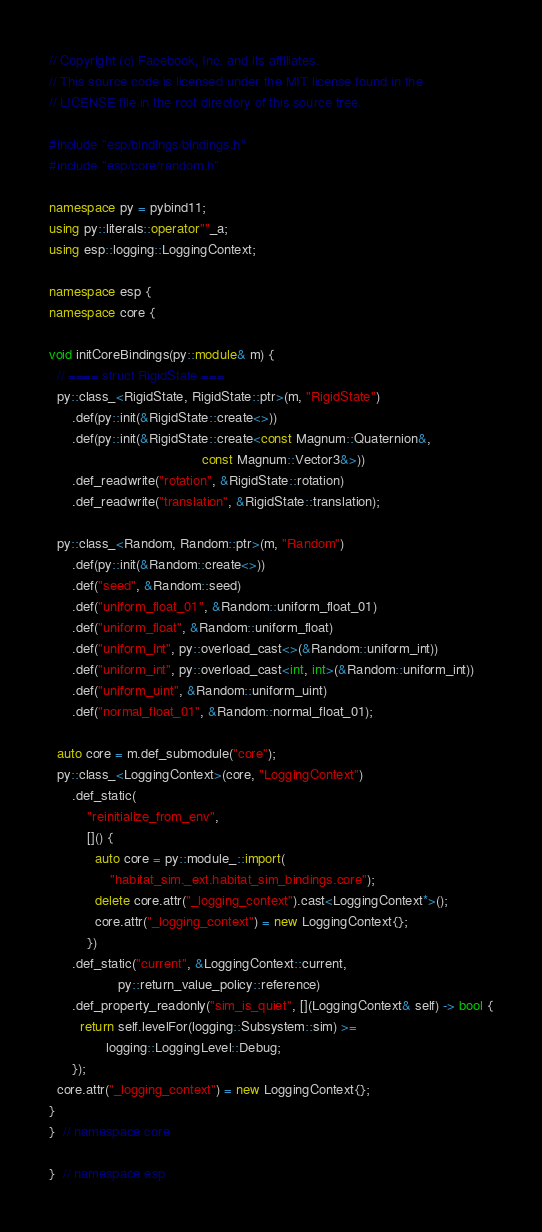<code> <loc_0><loc_0><loc_500><loc_500><_C++_>// Copyright (c) Facebook, Inc. and its affiliates.
// This source code is licensed under the MIT license found in the
// LICENSE file in the root directory of this source tree.

#include "esp/bindings/bindings.h"
#include "esp/core/random.h"

namespace py = pybind11;
using py::literals::operator""_a;
using esp::logging::LoggingContext;

namespace esp {
namespace core {

void initCoreBindings(py::module& m) {
  // ==== struct RigidState ===
  py::class_<RigidState, RigidState::ptr>(m, "RigidState")
      .def(py::init(&RigidState::create<>))
      .def(py::init(&RigidState::create<const Magnum::Quaternion&,
                                        const Magnum::Vector3&>))
      .def_readwrite("rotation", &RigidState::rotation)
      .def_readwrite("translation", &RigidState::translation);

  py::class_<Random, Random::ptr>(m, "Random")
      .def(py::init(&Random::create<>))
      .def("seed", &Random::seed)
      .def("uniform_float_01", &Random::uniform_float_01)
      .def("uniform_float", &Random::uniform_float)
      .def("uniform_int", py::overload_cast<>(&Random::uniform_int))
      .def("uniform_int", py::overload_cast<int, int>(&Random::uniform_int))
      .def("uniform_uint", &Random::uniform_uint)
      .def("normal_float_01", &Random::normal_float_01);

  auto core = m.def_submodule("core");
  py::class_<LoggingContext>(core, "LoggingContext")
      .def_static(
          "reinitialize_from_env",
          []() {
            auto core = py::module_::import(
                "habitat_sim._ext.habitat_sim_bindings.core");
            delete core.attr("_logging_context").cast<LoggingContext*>();
            core.attr("_logging_context") = new LoggingContext{};
          })
      .def_static("current", &LoggingContext::current,
                  py::return_value_policy::reference)
      .def_property_readonly("sim_is_quiet", [](LoggingContext& self) -> bool {
        return self.levelFor(logging::Subsystem::sim) >=
               logging::LoggingLevel::Debug;
      });
  core.attr("_logging_context") = new LoggingContext{};
}
}  // namespace core

}  // namespace esp
</code> 